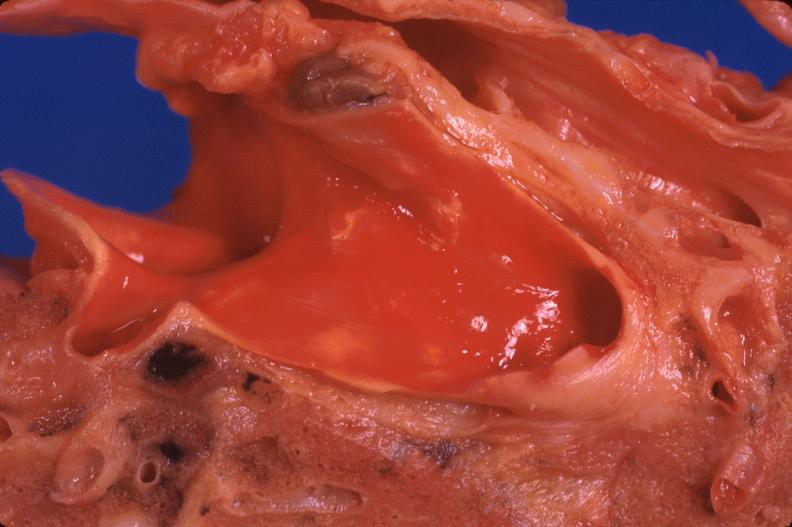s respiratory present?
Answer the question using a single word or phrase. Yes 